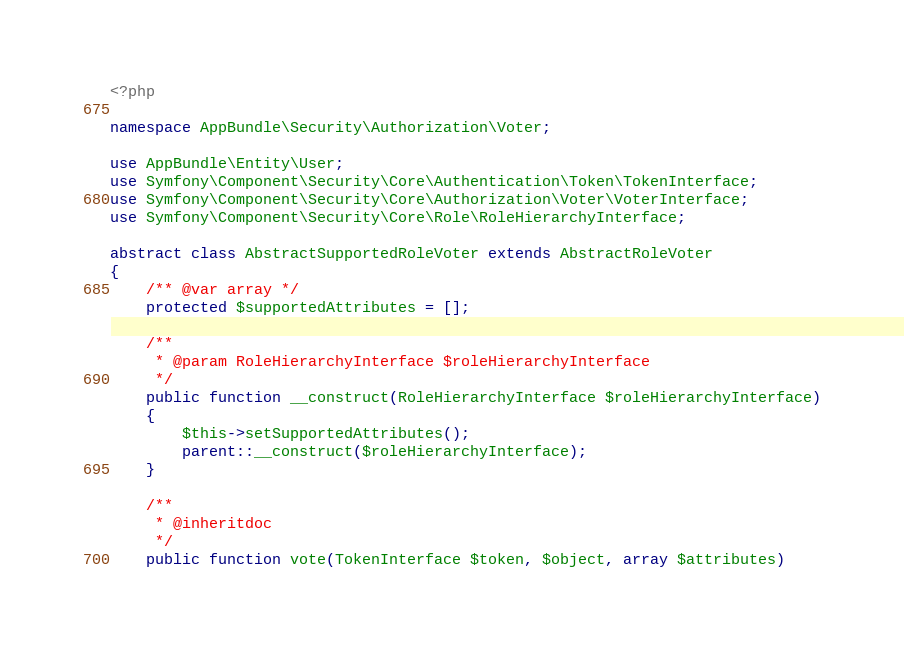<code> <loc_0><loc_0><loc_500><loc_500><_PHP_><?php

namespace AppBundle\Security\Authorization\Voter;

use AppBundle\Entity\User;
use Symfony\Component\Security\Core\Authentication\Token\TokenInterface;
use Symfony\Component\Security\Core\Authorization\Voter\VoterInterface;
use Symfony\Component\Security\Core\Role\RoleHierarchyInterface;

abstract class AbstractSupportedRoleVoter extends AbstractRoleVoter
{
    /** @var array */
    protected $supportedAttributes = [];

    /**
     * @param RoleHierarchyInterface $roleHierarchyInterface
     */
    public function __construct(RoleHierarchyInterface $roleHierarchyInterface)
    {
        $this->setSupportedAttributes();
        parent::__construct($roleHierarchyInterface);
    }

    /**
     * @inheritdoc
     */
    public function vote(TokenInterface $token, $object, array $attributes)</code> 